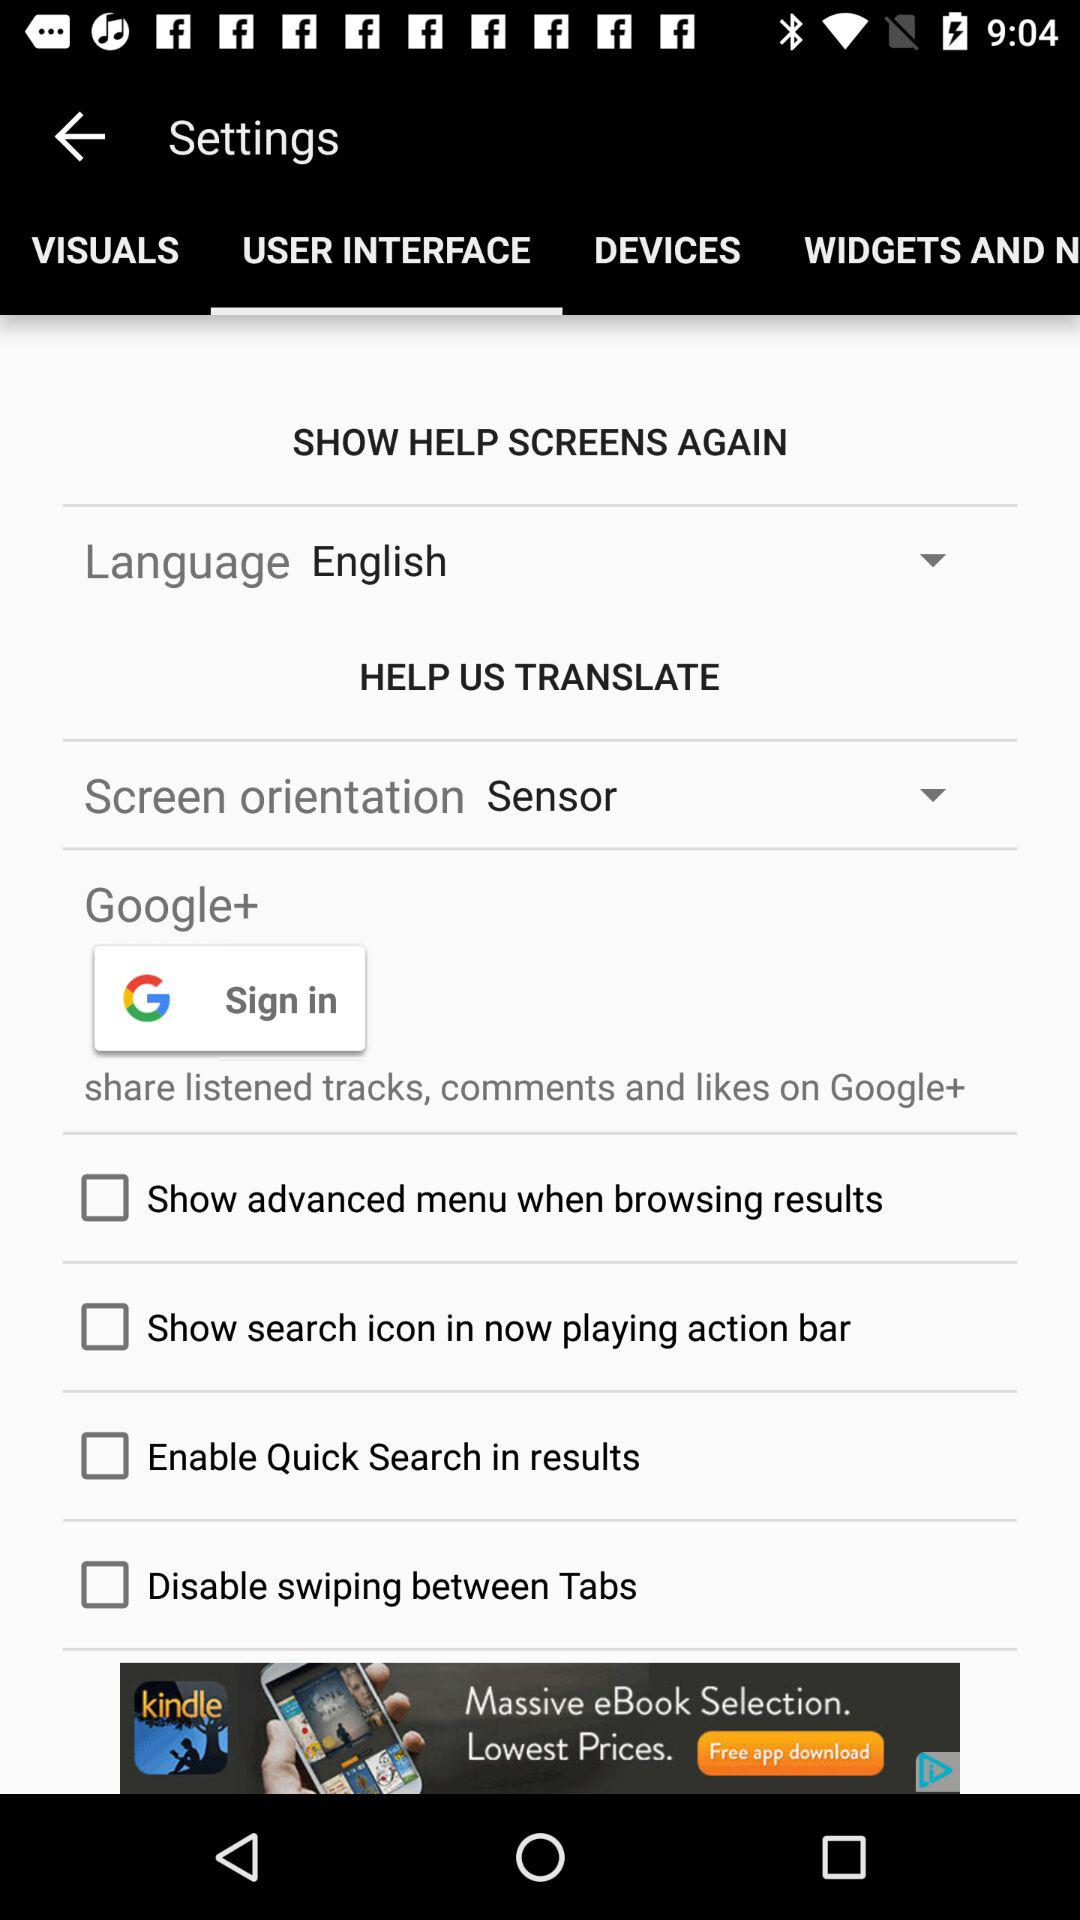Which option is selected in the settings? The selected option is the user interface. 